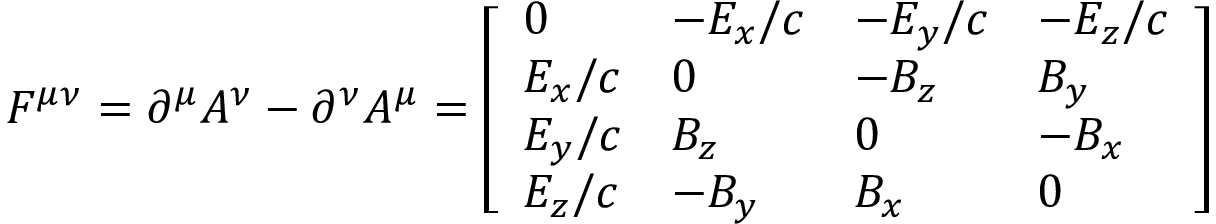<formula> <loc_0><loc_0><loc_500><loc_500>F ^ { \mu \nu } = \partial ^ { \mu } A ^ { \nu } - \partial ^ { \nu } A ^ { \mu } = { \left [ \begin{array} { l l l l } { 0 } & { - E _ { x } / c } & { - E _ { y } / c } & { - E _ { z } / c } \\ { E _ { x } / c } & { 0 } & { - B _ { z } } & { B _ { y } } \\ { E _ { y } / c } & { B _ { z } } & { 0 } & { - B _ { x } } \\ { E _ { z } / c } & { - B _ { y } } & { B _ { x } } & { 0 } \end{array} \right ] }</formula> 